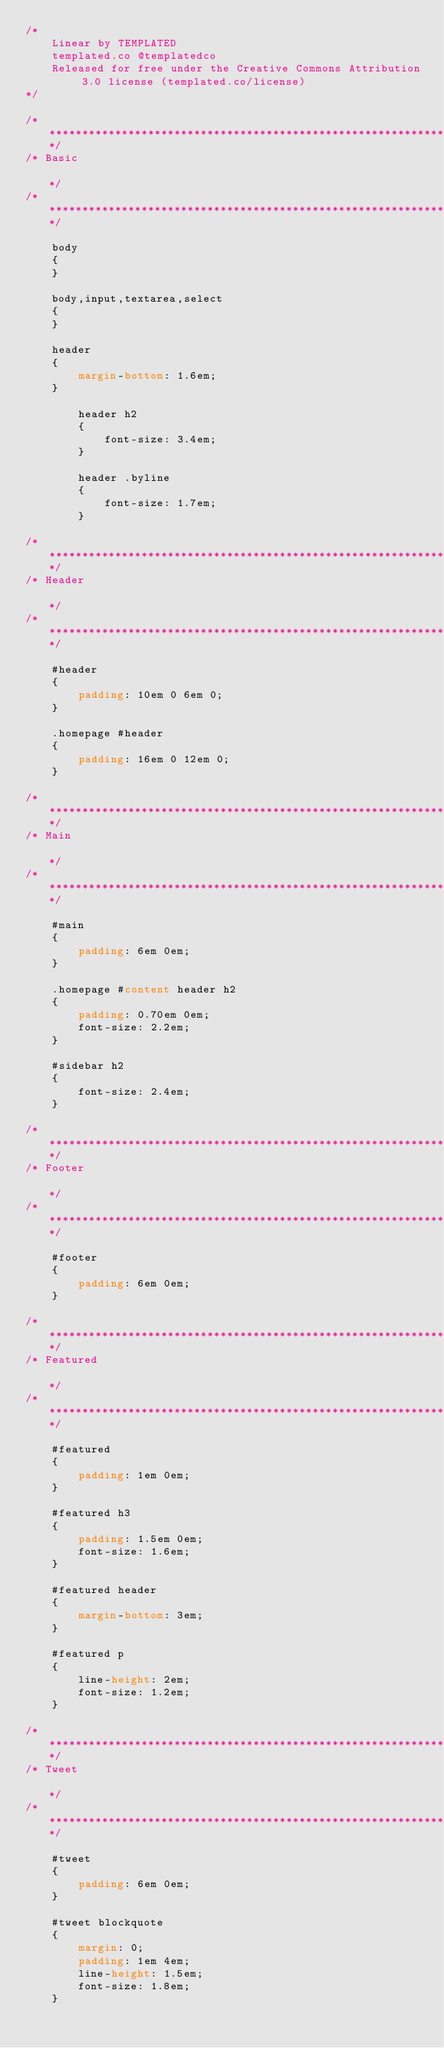<code> <loc_0><loc_0><loc_500><loc_500><_CSS_>/*
	Linear by TEMPLATED
    templated.co @templatedco
    Released for free under the Creative Commons Attribution 3.0 license (templated.co/license)
*/

/*********************************************************************************/
/* Basic                                                                         */
/*********************************************************************************/

	body
	{
	}

	body,input,textarea,select
	{
	}

	header
	{
		margin-bottom: 1.6em;
	}

		header h2
		{
			font-size: 3.4em;
		}

		header .byline
		{
			font-size: 1.7em;
		}

/*********************************************************************************/
/* Header                                                                        */
/*********************************************************************************/

	#header
	{
		padding: 10em 0 6em 0;
	}

	.homepage #header
	{
		padding: 16em 0 12em 0;
	}

/*********************************************************************************/
/* Main                                                                          */
/*********************************************************************************/

	#main
	{
		padding: 6em 0em;
	}

	.homepage #content header h2
	{
		padding: 0.70em 0em;
		font-size: 2.2em;
	}

	#sidebar h2
	{
		font-size: 2.4em;
	}

/*********************************************************************************/
/* Footer                                                                        */
/*********************************************************************************/

	#footer
	{
		padding: 6em 0em;
	}

/*********************************************************************************/
/* Featured                                                                      */
/*********************************************************************************/

	#featured
	{
		padding: 1em 0em;
	}

	#featured h3
	{
		padding: 1.5em 0em;
		font-size: 1.6em;
	}

	#featured header
	{
		margin-bottom: 3em;
	}

	#featured p
	{
		line-height: 2em;
		font-size: 1.2em;
	}

/*********************************************************************************/
/* Tweet                                                                         */
/*********************************************************************************/

	#tweet
	{
		padding: 6em 0em;
	}

	#tweet blockquote
	{
		margin: 0;
		padding: 1em 4em;
		line-height: 1.5em;
		font-size: 1.8em;
	}
</code> 